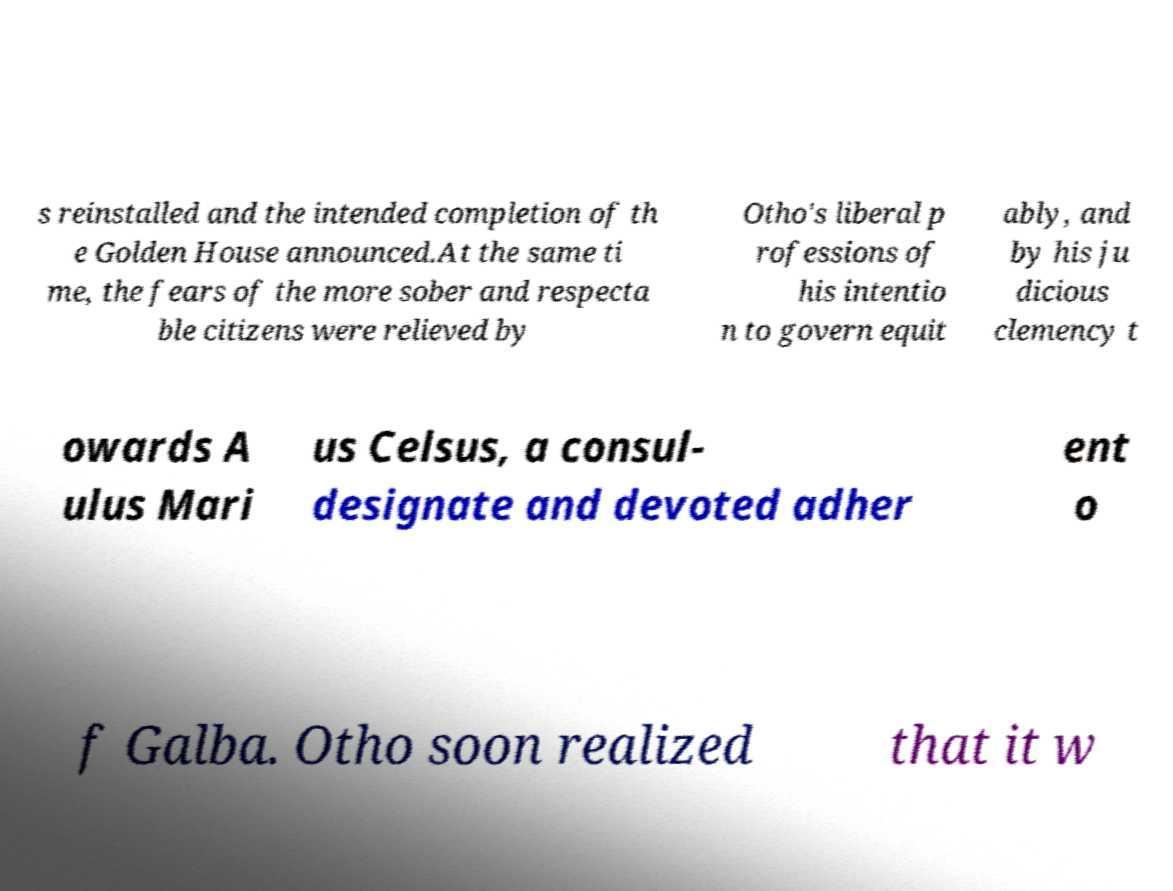Can you read and provide the text displayed in the image?This photo seems to have some interesting text. Can you extract and type it out for me? s reinstalled and the intended completion of th e Golden House announced.At the same ti me, the fears of the more sober and respecta ble citizens were relieved by Otho's liberal p rofessions of his intentio n to govern equit ably, and by his ju dicious clemency t owards A ulus Mari us Celsus, a consul- designate and devoted adher ent o f Galba. Otho soon realized that it w 